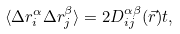Convert formula to latex. <formula><loc_0><loc_0><loc_500><loc_500>\langle \Delta r _ { i } ^ { \alpha } \Delta r _ { j } ^ { \beta } \rangle = 2 D _ { i j } ^ { \alpha \beta } ( \vec { r } ) t ,</formula> 